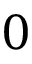<formula> <loc_0><loc_0><loc_500><loc_500>0</formula> 